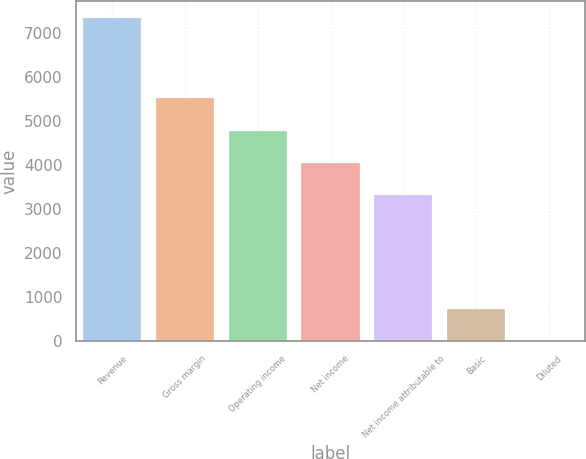<chart> <loc_0><loc_0><loc_500><loc_500><bar_chart><fcel>Revenue<fcel>Gross margin<fcel>Operating income<fcel>Net income<fcel>Net income attributable to<fcel>Basic<fcel>Diluted<nl><fcel>7351<fcel>5513.49<fcel>4778.66<fcel>4043.83<fcel>3309<fcel>737.5<fcel>2.67<nl></chart> 